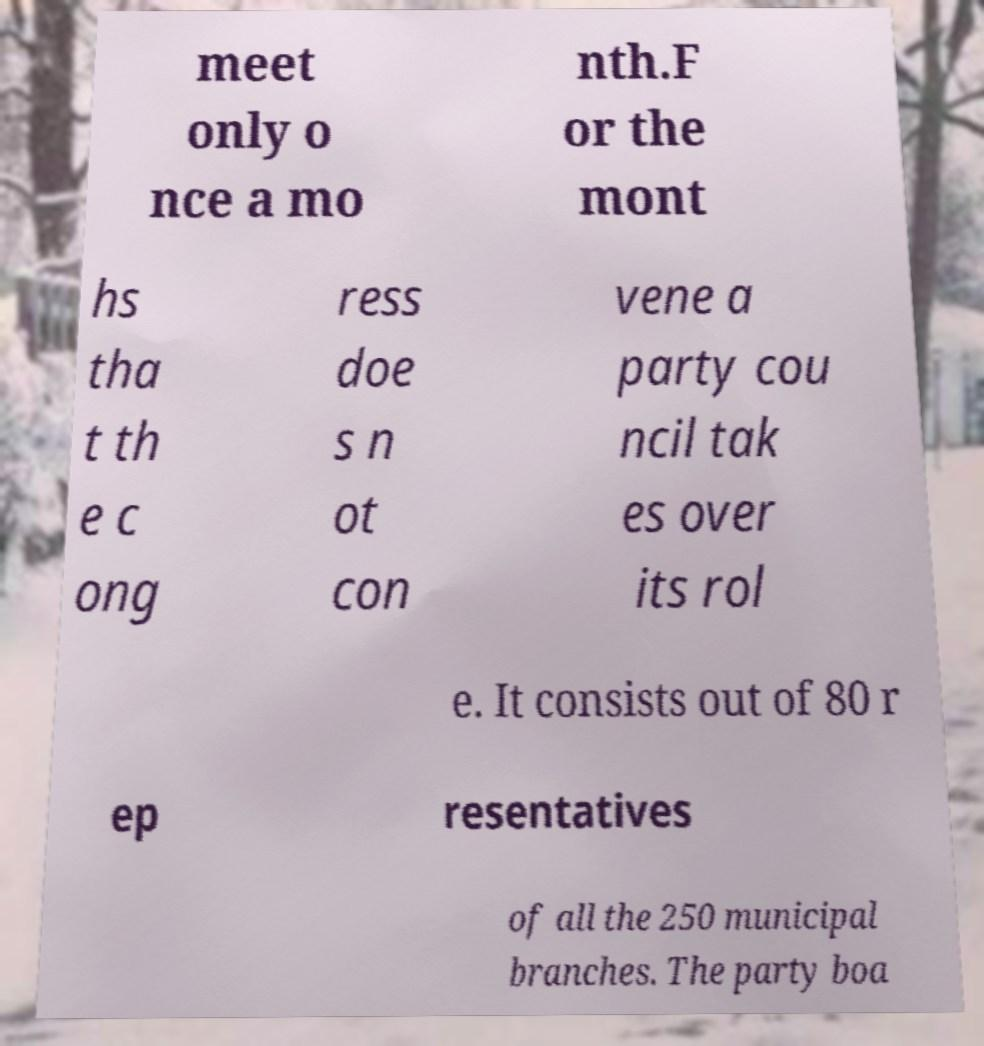Can you read and provide the text displayed in the image?This photo seems to have some interesting text. Can you extract and type it out for me? meet only o nce a mo nth.F or the mont hs tha t th e c ong ress doe s n ot con vene a party cou ncil tak es over its rol e. It consists out of 80 r ep resentatives of all the 250 municipal branches. The party boa 